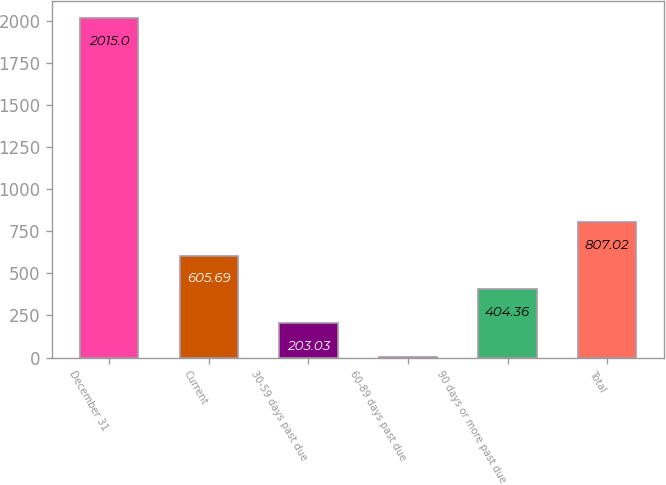<chart> <loc_0><loc_0><loc_500><loc_500><bar_chart><fcel>December 31<fcel>Current<fcel>30-59 days past due<fcel>60-89 days past due<fcel>90 days or more past due<fcel>Total<nl><fcel>2015<fcel>605.69<fcel>203.03<fcel>1.7<fcel>404.36<fcel>807.02<nl></chart> 